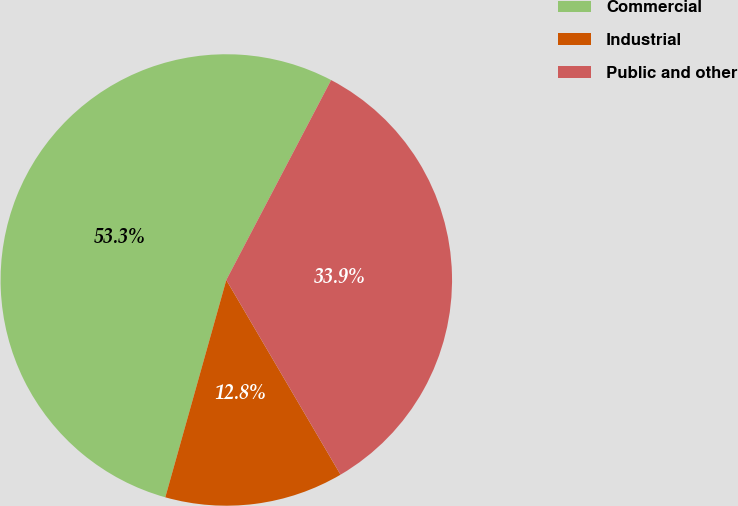Convert chart to OTSL. <chart><loc_0><loc_0><loc_500><loc_500><pie_chart><fcel>Commercial<fcel>Industrial<fcel>Public and other<nl><fcel>53.33%<fcel>12.8%<fcel>33.87%<nl></chart> 